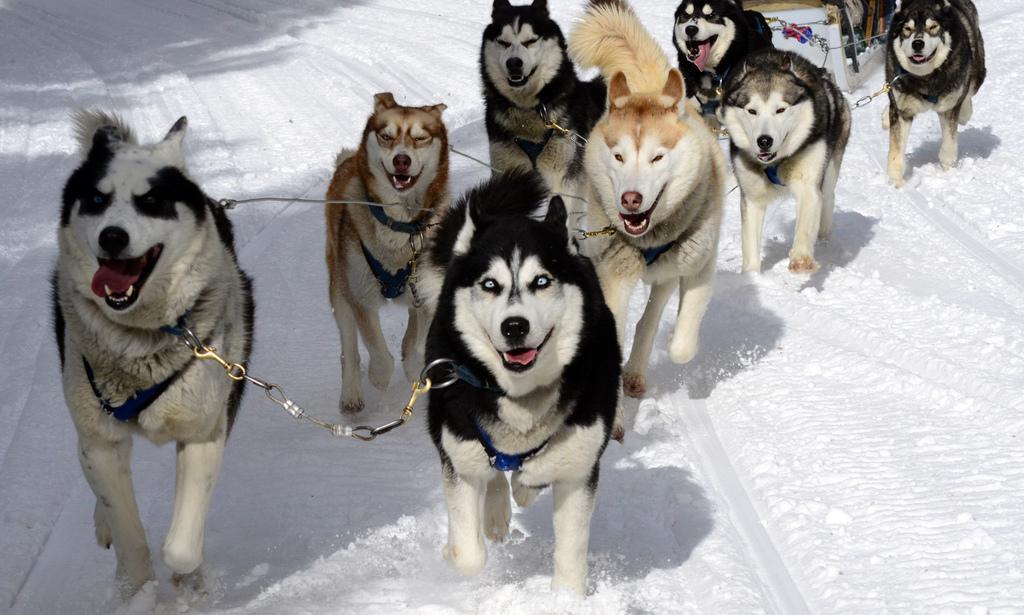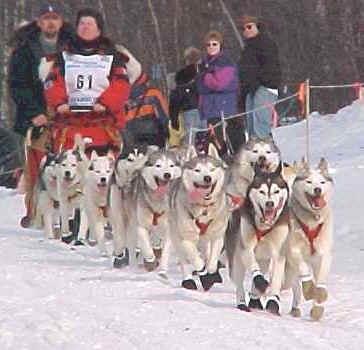The first image is the image on the left, the second image is the image on the right. For the images shown, is this caption "The Huskies are running in both images." true? Answer yes or no. Yes. The first image is the image on the left, the second image is the image on the right. Considering the images on both sides, is "Some dogs are wearing booties." valid? Answer yes or no. Yes. 